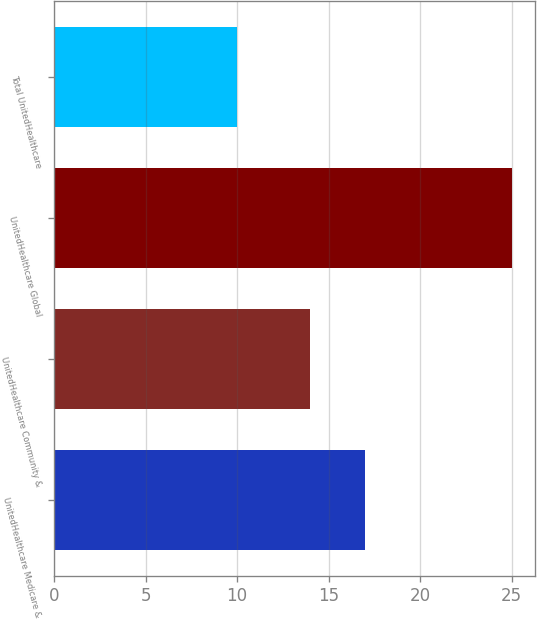Convert chart. <chart><loc_0><loc_0><loc_500><loc_500><bar_chart><fcel>UnitedHealthcare Medicare &<fcel>UnitedHealthcare Community &<fcel>UnitedHealthcare Global<fcel>Total UnitedHealthcare<nl><fcel>17<fcel>14<fcel>25<fcel>10<nl></chart> 